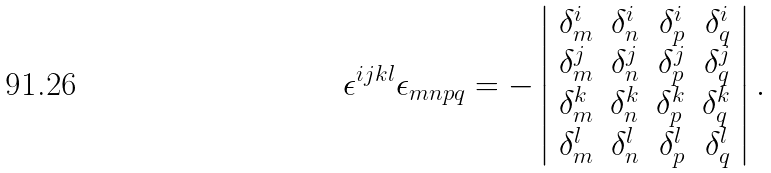Convert formula to latex. <formula><loc_0><loc_0><loc_500><loc_500>\epsilon ^ { i j k l } \epsilon _ { m n p q } = - \left | \begin{array} { r r r r } \delta ^ { i } _ { m } & \delta ^ { i } _ { n } & \delta ^ { i } _ { p } & \delta ^ { i } _ { q } \\ \delta ^ { j } _ { m } & \delta ^ { j } _ { n } & \delta ^ { j } _ { p } & \delta ^ { j } _ { q } \\ \delta ^ { k } _ { m } & \delta ^ { k } _ { n } & \delta ^ { k } _ { p } & \delta ^ { k } _ { q } \\ \delta ^ { l } _ { m } & \delta ^ { l } _ { n } & \delta ^ { l } _ { p } & \delta ^ { l } _ { q } \end{array} \right | .</formula> 